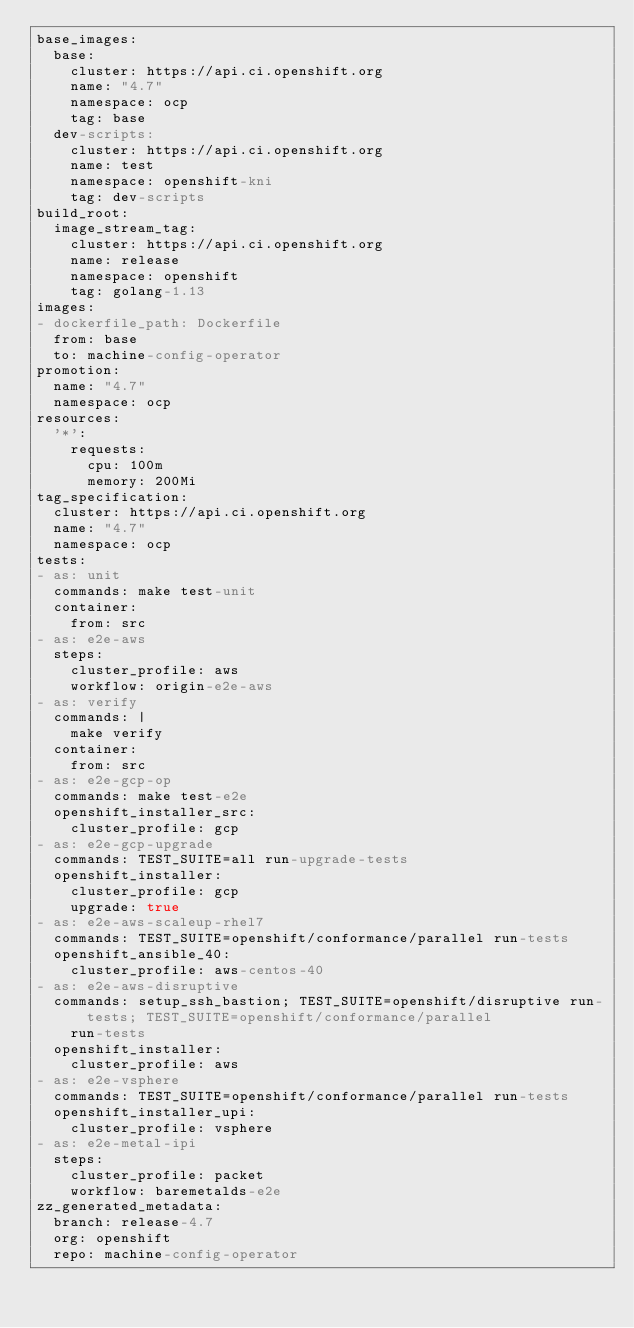Convert code to text. <code><loc_0><loc_0><loc_500><loc_500><_YAML_>base_images:
  base:
    cluster: https://api.ci.openshift.org
    name: "4.7"
    namespace: ocp
    tag: base
  dev-scripts:
    cluster: https://api.ci.openshift.org
    name: test
    namespace: openshift-kni
    tag: dev-scripts
build_root:
  image_stream_tag:
    cluster: https://api.ci.openshift.org
    name: release
    namespace: openshift
    tag: golang-1.13
images:
- dockerfile_path: Dockerfile
  from: base
  to: machine-config-operator
promotion:
  name: "4.7"
  namespace: ocp
resources:
  '*':
    requests:
      cpu: 100m
      memory: 200Mi
tag_specification:
  cluster: https://api.ci.openshift.org
  name: "4.7"
  namespace: ocp
tests:
- as: unit
  commands: make test-unit
  container:
    from: src
- as: e2e-aws
  steps:
    cluster_profile: aws
    workflow: origin-e2e-aws
- as: verify
  commands: |
    make verify
  container:
    from: src
- as: e2e-gcp-op
  commands: make test-e2e
  openshift_installer_src:
    cluster_profile: gcp
- as: e2e-gcp-upgrade
  commands: TEST_SUITE=all run-upgrade-tests
  openshift_installer:
    cluster_profile: gcp
    upgrade: true
- as: e2e-aws-scaleup-rhel7
  commands: TEST_SUITE=openshift/conformance/parallel run-tests
  openshift_ansible_40:
    cluster_profile: aws-centos-40
- as: e2e-aws-disruptive
  commands: setup_ssh_bastion; TEST_SUITE=openshift/disruptive run-tests; TEST_SUITE=openshift/conformance/parallel
    run-tests
  openshift_installer:
    cluster_profile: aws
- as: e2e-vsphere
  commands: TEST_SUITE=openshift/conformance/parallel run-tests
  openshift_installer_upi:
    cluster_profile: vsphere
- as: e2e-metal-ipi
  steps:
    cluster_profile: packet
    workflow: baremetalds-e2e
zz_generated_metadata:
  branch: release-4.7
  org: openshift
  repo: machine-config-operator
</code> 